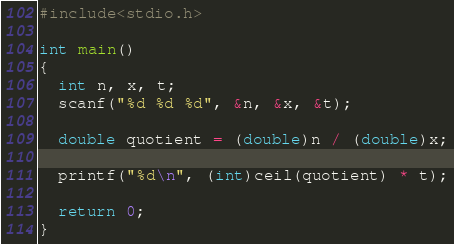Convert code to text. <code><loc_0><loc_0><loc_500><loc_500><_C_>#include<stdio.h>

int main()
{
  int n, x, t;
  scanf("%d %d %d", &n, &x, &t);
  
  double quotient = (double)n / (double)x;
  
  printf("%d\n", (int)ceil(quotient) * t);
  
  return 0;
}</code> 